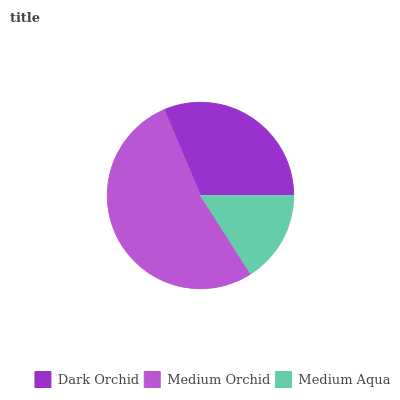Is Medium Aqua the minimum?
Answer yes or no. Yes. Is Medium Orchid the maximum?
Answer yes or no. Yes. Is Medium Orchid the minimum?
Answer yes or no. No. Is Medium Aqua the maximum?
Answer yes or no. No. Is Medium Orchid greater than Medium Aqua?
Answer yes or no. Yes. Is Medium Aqua less than Medium Orchid?
Answer yes or no. Yes. Is Medium Aqua greater than Medium Orchid?
Answer yes or no. No. Is Medium Orchid less than Medium Aqua?
Answer yes or no. No. Is Dark Orchid the high median?
Answer yes or no. Yes. Is Dark Orchid the low median?
Answer yes or no. Yes. Is Medium Orchid the high median?
Answer yes or no. No. Is Medium Aqua the low median?
Answer yes or no. No. 